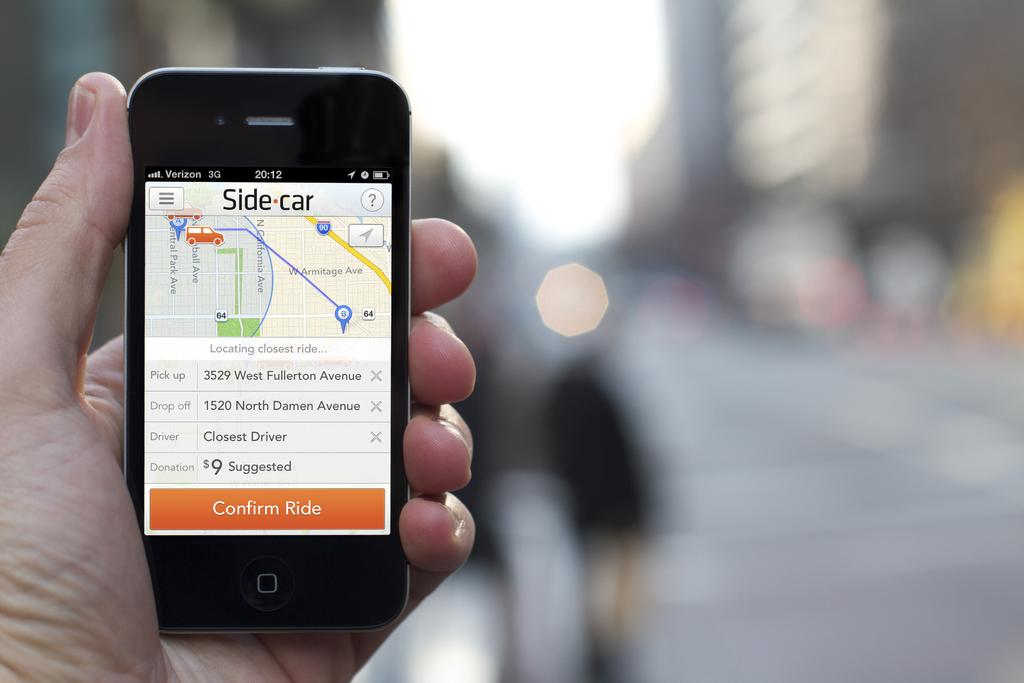Provide a one-sentence caption for the provided image. A hand holding a phone that is waiting for a Side car. 